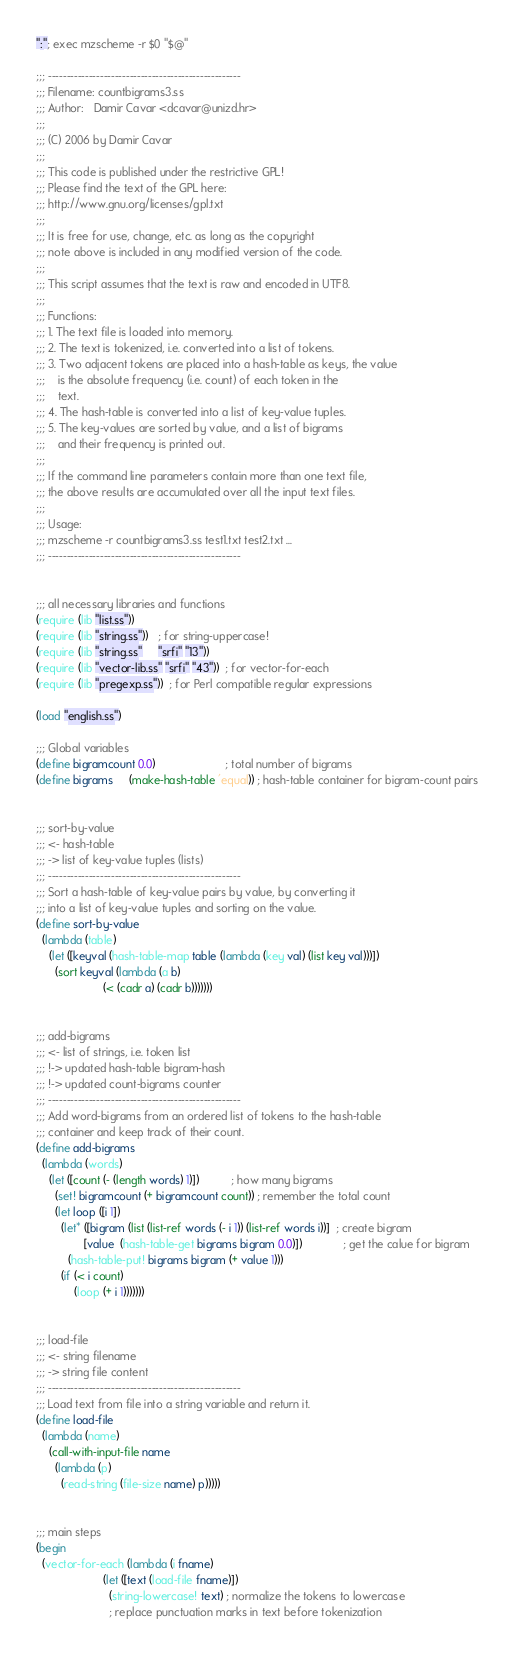<code> <loc_0><loc_0><loc_500><loc_500><_Scheme_>":"; exec mzscheme -r $0 "$@"

;;; ----------------------------------------------------
;;; Filename: countbigrams3.ss
;;; Author:   Damir Cavar <dcavar@unizd.hr>
;;;
;;; (C) 2006 by Damir Cavar
;;;
;;; This code is published under the restrictive GPL!
;;; Please find the text of the GPL here:
;;; http://www.gnu.org/licenses/gpl.txt
;;; 
;;; It is free for use, change, etc. as long as the copyright
;;; note above is included in any modified version of the code.
;;; 
;;; This script assumes that the text is raw and encoded in UTF8.
;;;
;;; Functions:
;;; 1. The text file is loaded into memory.
;;; 2. The text is tokenized, i.e. converted into a list of tokens.
;;; 3. Two adjacent tokens are placed into a hash-table as keys, the value
;;;    is the absolute frequency (i.e. count) of each token in the
;;;    text.
;;; 4. The hash-table is converted into a list of key-value tuples.
;;; 5. The key-values are sorted by value, and a list of bigrams
;;;    and their frequency is printed out.
;;;
;;; If the command line parameters contain more than one text file,
;;; the above results are accumulated over all the input text files.
;;;
;;; Usage:
;;; mzscheme -r countbigrams3.ss test1.txt test2.txt ...
;;; ----------------------------------------------------


;;; all necessary libraries and functions
(require (lib "list.ss"))
(require (lib "string.ss"))   ; for string-uppercase!
(require (lib "string.ss"     "srfi" "13"))
(require (lib "vector-lib.ss" "srfi" "43"))  ; for vector-for-each
(require (lib "pregexp.ss"))  ; for Perl compatible regular expressions

(load "english.ss")

;;; Global variables
(define bigramcount 0.0)                      ; total number of bigrams
(define bigrams     (make-hash-table 'equal)) ; hash-table container for bigram-count pairs


;;; sort-by-value
;;; <- hash-table
;;; -> list of key-value tuples (lists)
;;; ----------------------------------------------------
;;; Sort a hash-table of key-value pairs by value, by converting it
;;; into a list of key-value tuples and sorting on the value.
(define sort-by-value
  (lambda (table)
    (let ([keyval (hash-table-map table (lambda (key val) (list key val)))])
      (sort keyval (lambda (a b)
                     (< (cadr a) (cadr b)))))))


;;; add-bigrams
;;; <- list of strings, i.e. token list
;;; !-> updated hash-table bigram-hash
;;; !-> updated count-bigrams counter
;;; ----------------------------------------------------
;;; Add word-bigrams from an ordered list of tokens to the hash-table
;;; container and keep track of their count.
(define add-bigrams
  (lambda (words)
    (let ([count (- (length words) 1)])          ; how many bigrams
      (set! bigramcount (+ bigramcount count)) ; remember the total count
      (let loop ([i 1])
        (let* ([bigram (list (list-ref words (- i 1)) (list-ref words i))]  ; create bigram
               [value  (hash-table-get bigrams bigram 0.0)])             ; get the calue for bigram
          (hash-table-put! bigrams bigram (+ value 1)))
        (if (< i count)
            (loop (+ i 1)))))))


;;; load-file
;;; <- string filename
;;; -> string file content
;;; ----------------------------------------------------
;;; Load text from file into a string variable and return it.
(define load-file
  (lambda (name)
    (call-with-input-file name
      (lambda (p)
        (read-string (file-size name) p)))))


;;; main steps
(begin 
  (vector-for-each (lambda (i fname)
                     (let ([text (load-file fname)])
                       (string-lowercase! text) ; normalize the tokens to lowercase
                       ; replace punctuation marks in text before tokenization</code> 